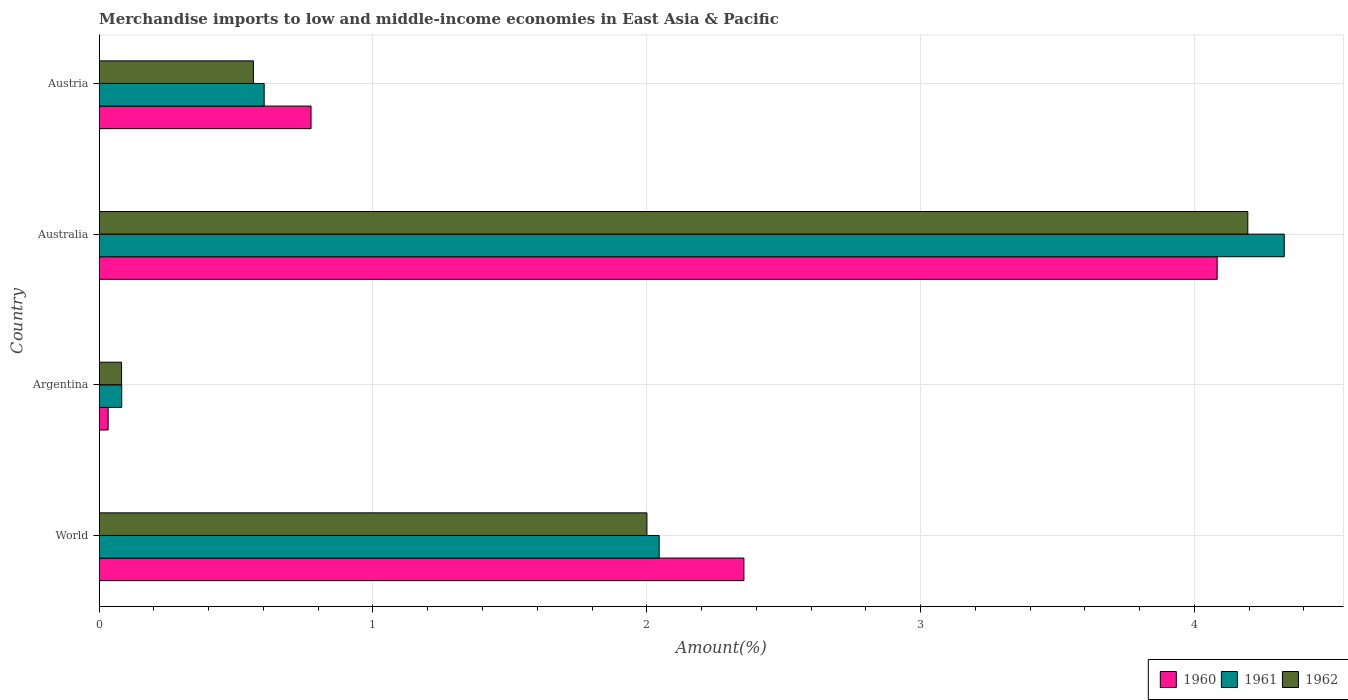How many groups of bars are there?
Ensure brevity in your answer.  4. What is the label of the 4th group of bars from the top?
Give a very brief answer. World. In how many cases, is the number of bars for a given country not equal to the number of legend labels?
Keep it short and to the point. 0. What is the percentage of amount earned from merchandise imports in 1960 in Argentina?
Provide a short and direct response. 0.03. Across all countries, what is the maximum percentage of amount earned from merchandise imports in 1961?
Provide a succinct answer. 4.33. Across all countries, what is the minimum percentage of amount earned from merchandise imports in 1961?
Give a very brief answer. 0.08. What is the total percentage of amount earned from merchandise imports in 1962 in the graph?
Your answer should be very brief. 6.84. What is the difference between the percentage of amount earned from merchandise imports in 1961 in Austria and that in World?
Offer a terse response. -1.44. What is the difference between the percentage of amount earned from merchandise imports in 1961 in Argentina and the percentage of amount earned from merchandise imports in 1960 in Austria?
Ensure brevity in your answer.  -0.69. What is the average percentage of amount earned from merchandise imports in 1962 per country?
Provide a short and direct response. 1.71. What is the difference between the percentage of amount earned from merchandise imports in 1960 and percentage of amount earned from merchandise imports in 1962 in World?
Make the answer very short. 0.35. What is the ratio of the percentage of amount earned from merchandise imports in 1962 in Australia to that in World?
Ensure brevity in your answer.  2.1. What is the difference between the highest and the second highest percentage of amount earned from merchandise imports in 1960?
Provide a succinct answer. 1.73. What is the difference between the highest and the lowest percentage of amount earned from merchandise imports in 1962?
Your response must be concise. 4.11. What does the 1st bar from the bottom in World represents?
Keep it short and to the point. 1960. How many bars are there?
Your answer should be very brief. 12. Are the values on the major ticks of X-axis written in scientific E-notation?
Offer a terse response. No. Where does the legend appear in the graph?
Offer a very short reply. Bottom right. What is the title of the graph?
Your answer should be very brief. Merchandise imports to low and middle-income economies in East Asia & Pacific. Does "2001" appear as one of the legend labels in the graph?
Keep it short and to the point. No. What is the label or title of the X-axis?
Keep it short and to the point. Amount(%). What is the label or title of the Y-axis?
Offer a very short reply. Country. What is the Amount(%) in 1960 in World?
Provide a succinct answer. 2.35. What is the Amount(%) of 1961 in World?
Your answer should be compact. 2.05. What is the Amount(%) in 1962 in World?
Make the answer very short. 2. What is the Amount(%) of 1960 in Argentina?
Make the answer very short. 0.03. What is the Amount(%) of 1961 in Argentina?
Give a very brief answer. 0.08. What is the Amount(%) of 1962 in Argentina?
Give a very brief answer. 0.08. What is the Amount(%) in 1960 in Australia?
Make the answer very short. 4.08. What is the Amount(%) in 1961 in Australia?
Ensure brevity in your answer.  4.33. What is the Amount(%) in 1962 in Australia?
Provide a succinct answer. 4.2. What is the Amount(%) in 1960 in Austria?
Give a very brief answer. 0.77. What is the Amount(%) in 1961 in Austria?
Ensure brevity in your answer.  0.6. What is the Amount(%) of 1962 in Austria?
Offer a very short reply. 0.56. Across all countries, what is the maximum Amount(%) of 1960?
Provide a short and direct response. 4.08. Across all countries, what is the maximum Amount(%) in 1961?
Offer a terse response. 4.33. Across all countries, what is the maximum Amount(%) in 1962?
Offer a terse response. 4.2. Across all countries, what is the minimum Amount(%) in 1960?
Make the answer very short. 0.03. Across all countries, what is the minimum Amount(%) in 1961?
Your response must be concise. 0.08. Across all countries, what is the minimum Amount(%) of 1962?
Offer a very short reply. 0.08. What is the total Amount(%) of 1960 in the graph?
Keep it short and to the point. 7.24. What is the total Amount(%) in 1961 in the graph?
Offer a very short reply. 7.06. What is the total Amount(%) in 1962 in the graph?
Offer a very short reply. 6.84. What is the difference between the Amount(%) in 1960 in World and that in Argentina?
Your answer should be very brief. 2.32. What is the difference between the Amount(%) of 1961 in World and that in Argentina?
Provide a succinct answer. 1.96. What is the difference between the Amount(%) of 1962 in World and that in Argentina?
Your response must be concise. 1.92. What is the difference between the Amount(%) of 1960 in World and that in Australia?
Your answer should be compact. -1.73. What is the difference between the Amount(%) of 1961 in World and that in Australia?
Offer a very short reply. -2.28. What is the difference between the Amount(%) in 1962 in World and that in Australia?
Your answer should be very brief. -2.19. What is the difference between the Amount(%) in 1960 in World and that in Austria?
Your answer should be very brief. 1.58. What is the difference between the Amount(%) in 1961 in World and that in Austria?
Make the answer very short. 1.44. What is the difference between the Amount(%) in 1962 in World and that in Austria?
Your response must be concise. 1.44. What is the difference between the Amount(%) in 1960 in Argentina and that in Australia?
Your response must be concise. -4.05. What is the difference between the Amount(%) of 1961 in Argentina and that in Australia?
Provide a short and direct response. -4.25. What is the difference between the Amount(%) in 1962 in Argentina and that in Australia?
Your answer should be compact. -4.11. What is the difference between the Amount(%) of 1960 in Argentina and that in Austria?
Your response must be concise. -0.74. What is the difference between the Amount(%) in 1961 in Argentina and that in Austria?
Provide a succinct answer. -0.52. What is the difference between the Amount(%) of 1962 in Argentina and that in Austria?
Offer a terse response. -0.48. What is the difference between the Amount(%) in 1960 in Australia and that in Austria?
Provide a succinct answer. 3.31. What is the difference between the Amount(%) of 1961 in Australia and that in Austria?
Provide a succinct answer. 3.73. What is the difference between the Amount(%) in 1962 in Australia and that in Austria?
Provide a succinct answer. 3.63. What is the difference between the Amount(%) of 1960 in World and the Amount(%) of 1961 in Argentina?
Make the answer very short. 2.27. What is the difference between the Amount(%) of 1960 in World and the Amount(%) of 1962 in Argentina?
Your answer should be compact. 2.27. What is the difference between the Amount(%) of 1961 in World and the Amount(%) of 1962 in Argentina?
Your answer should be compact. 1.96. What is the difference between the Amount(%) in 1960 in World and the Amount(%) in 1961 in Australia?
Keep it short and to the point. -1.97. What is the difference between the Amount(%) of 1960 in World and the Amount(%) of 1962 in Australia?
Ensure brevity in your answer.  -1.84. What is the difference between the Amount(%) in 1961 in World and the Amount(%) in 1962 in Australia?
Keep it short and to the point. -2.15. What is the difference between the Amount(%) in 1960 in World and the Amount(%) in 1961 in Austria?
Keep it short and to the point. 1.75. What is the difference between the Amount(%) in 1960 in World and the Amount(%) in 1962 in Austria?
Ensure brevity in your answer.  1.79. What is the difference between the Amount(%) in 1961 in World and the Amount(%) in 1962 in Austria?
Your answer should be compact. 1.48. What is the difference between the Amount(%) in 1960 in Argentina and the Amount(%) in 1961 in Australia?
Offer a terse response. -4.3. What is the difference between the Amount(%) of 1960 in Argentina and the Amount(%) of 1962 in Australia?
Provide a succinct answer. -4.16. What is the difference between the Amount(%) of 1961 in Argentina and the Amount(%) of 1962 in Australia?
Ensure brevity in your answer.  -4.11. What is the difference between the Amount(%) in 1960 in Argentina and the Amount(%) in 1961 in Austria?
Your answer should be compact. -0.57. What is the difference between the Amount(%) of 1960 in Argentina and the Amount(%) of 1962 in Austria?
Offer a terse response. -0.53. What is the difference between the Amount(%) of 1961 in Argentina and the Amount(%) of 1962 in Austria?
Keep it short and to the point. -0.48. What is the difference between the Amount(%) in 1960 in Australia and the Amount(%) in 1961 in Austria?
Ensure brevity in your answer.  3.48. What is the difference between the Amount(%) of 1960 in Australia and the Amount(%) of 1962 in Austria?
Ensure brevity in your answer.  3.52. What is the difference between the Amount(%) of 1961 in Australia and the Amount(%) of 1962 in Austria?
Your response must be concise. 3.77. What is the average Amount(%) in 1960 per country?
Your answer should be very brief. 1.81. What is the average Amount(%) in 1961 per country?
Your answer should be compact. 1.76. What is the average Amount(%) in 1962 per country?
Give a very brief answer. 1.71. What is the difference between the Amount(%) of 1960 and Amount(%) of 1961 in World?
Keep it short and to the point. 0.31. What is the difference between the Amount(%) of 1960 and Amount(%) of 1962 in World?
Your response must be concise. 0.35. What is the difference between the Amount(%) in 1961 and Amount(%) in 1962 in World?
Your answer should be compact. 0.04. What is the difference between the Amount(%) of 1960 and Amount(%) of 1961 in Argentina?
Offer a terse response. -0.05. What is the difference between the Amount(%) of 1960 and Amount(%) of 1962 in Argentina?
Make the answer very short. -0.05. What is the difference between the Amount(%) in 1960 and Amount(%) in 1961 in Australia?
Make the answer very short. -0.24. What is the difference between the Amount(%) of 1960 and Amount(%) of 1962 in Australia?
Offer a terse response. -0.11. What is the difference between the Amount(%) of 1961 and Amount(%) of 1962 in Australia?
Ensure brevity in your answer.  0.13. What is the difference between the Amount(%) of 1960 and Amount(%) of 1961 in Austria?
Your answer should be very brief. 0.17. What is the difference between the Amount(%) of 1960 and Amount(%) of 1962 in Austria?
Provide a succinct answer. 0.21. What is the difference between the Amount(%) in 1961 and Amount(%) in 1962 in Austria?
Provide a succinct answer. 0.04. What is the ratio of the Amount(%) in 1960 in World to that in Argentina?
Your answer should be compact. 72.25. What is the ratio of the Amount(%) of 1961 in World to that in Argentina?
Give a very brief answer. 24.89. What is the ratio of the Amount(%) of 1962 in World to that in Argentina?
Ensure brevity in your answer.  24.5. What is the ratio of the Amount(%) in 1960 in World to that in Australia?
Offer a very short reply. 0.58. What is the ratio of the Amount(%) in 1961 in World to that in Australia?
Make the answer very short. 0.47. What is the ratio of the Amount(%) in 1962 in World to that in Australia?
Provide a short and direct response. 0.48. What is the ratio of the Amount(%) of 1960 in World to that in Austria?
Your response must be concise. 3.04. What is the ratio of the Amount(%) in 1961 in World to that in Austria?
Make the answer very short. 3.39. What is the ratio of the Amount(%) in 1962 in World to that in Austria?
Keep it short and to the point. 3.55. What is the ratio of the Amount(%) in 1960 in Argentina to that in Australia?
Your response must be concise. 0.01. What is the ratio of the Amount(%) in 1961 in Argentina to that in Australia?
Your response must be concise. 0.02. What is the ratio of the Amount(%) of 1962 in Argentina to that in Australia?
Your answer should be very brief. 0.02. What is the ratio of the Amount(%) of 1960 in Argentina to that in Austria?
Provide a short and direct response. 0.04. What is the ratio of the Amount(%) of 1961 in Argentina to that in Austria?
Offer a terse response. 0.14. What is the ratio of the Amount(%) of 1962 in Argentina to that in Austria?
Offer a terse response. 0.14. What is the ratio of the Amount(%) of 1960 in Australia to that in Austria?
Offer a terse response. 5.28. What is the ratio of the Amount(%) in 1961 in Australia to that in Austria?
Offer a very short reply. 7.18. What is the ratio of the Amount(%) in 1962 in Australia to that in Austria?
Your answer should be very brief. 7.45. What is the difference between the highest and the second highest Amount(%) in 1960?
Offer a terse response. 1.73. What is the difference between the highest and the second highest Amount(%) in 1961?
Your answer should be very brief. 2.28. What is the difference between the highest and the second highest Amount(%) of 1962?
Keep it short and to the point. 2.19. What is the difference between the highest and the lowest Amount(%) in 1960?
Offer a terse response. 4.05. What is the difference between the highest and the lowest Amount(%) in 1961?
Keep it short and to the point. 4.25. What is the difference between the highest and the lowest Amount(%) of 1962?
Provide a short and direct response. 4.11. 